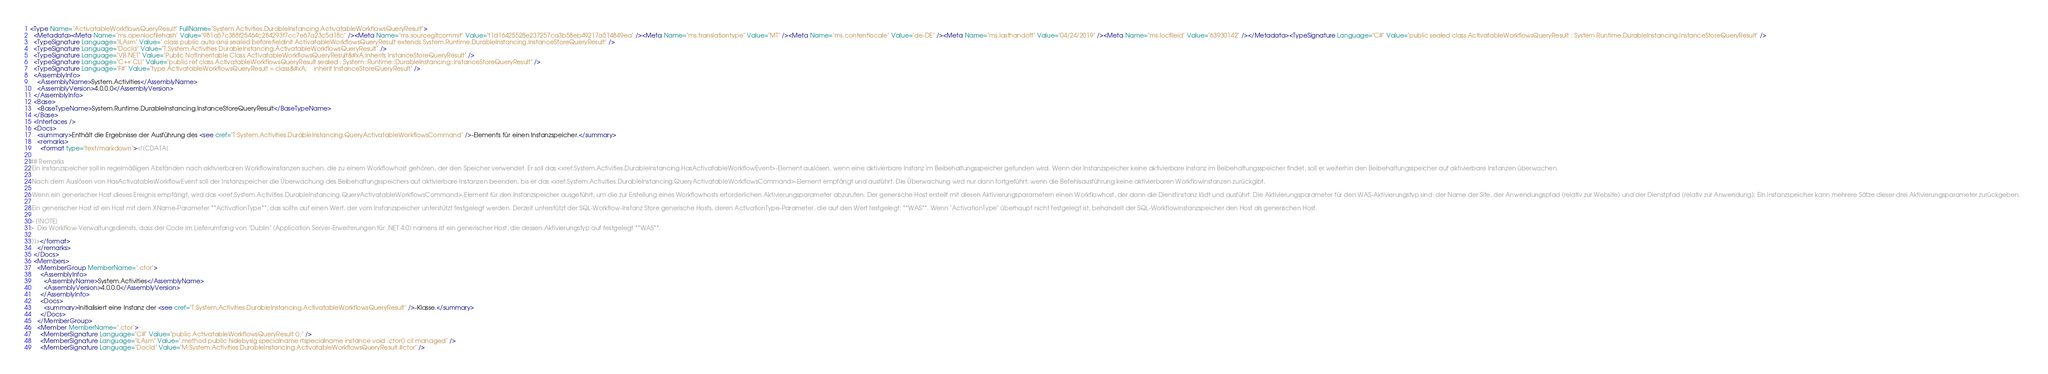Convert code to text. <code><loc_0><loc_0><loc_500><loc_500><_XML_><Type Name="ActivatableWorkflowsQueryResult" FullName="System.Activities.DurableInstancing.ActivatableWorkflowsQueryResult">
  <Metadata><Meta Name="ms.openlocfilehash" Value="981a57c388f25464c284293f7cc7e67a23c5d18c" /><Meta Name="ms.sourcegitcommit" Value="f1d16425528e237257ca3b58eb49217a514849ea" /><Meta Name="ms.translationtype" Value="MT" /><Meta Name="ms.contentlocale" Value="de-DE" /><Meta Name="ms.lasthandoff" Value="04/24/2019" /><Meta Name="ms.locfileid" Value="63930142" /></Metadata><TypeSignature Language="C#" Value="public sealed class ActivatableWorkflowsQueryResult : System.Runtime.DurableInstancing.InstanceStoreQueryResult" />
  <TypeSignature Language="ILAsm" Value=".class public auto ansi sealed beforefieldinit ActivatableWorkflowsQueryResult extends System.Runtime.DurableInstancing.InstanceStoreQueryResult" />
  <TypeSignature Language="DocId" Value="T:System.Activities.DurableInstancing.ActivatableWorkflowsQueryResult" />
  <TypeSignature Language="VB.NET" Value="Public NotInheritable Class ActivatableWorkflowsQueryResult&#xA;Inherits InstanceStoreQueryResult" />
  <TypeSignature Language="C++ CLI" Value="public ref class ActivatableWorkflowsQueryResult sealed : System::Runtime::DurableInstancing::InstanceStoreQueryResult" />
  <TypeSignature Language="F#" Value="type ActivatableWorkflowsQueryResult = class&#xA;    inherit InstanceStoreQueryResult" />
  <AssemblyInfo>
    <AssemblyName>System.Activities</AssemblyName>
    <AssemblyVersion>4.0.0.0</AssemblyVersion>
  </AssemblyInfo>
  <Base>
    <BaseTypeName>System.Runtime.DurableInstancing.InstanceStoreQueryResult</BaseTypeName>
  </Base>
  <Interfaces />
  <Docs>
    <summary>Enthält die Ergebnisse der Ausführung des <see cref="T:System.Activities.DurableInstancing.QueryActivatableWorkflowsCommand" />-Elements für einen Instanzspeicher.</summary>
    <remarks>
      <format type="text/markdown"><![CDATA[  
  
## Remarks  
 Ein Instanzspeicher soll in regelmäßigen Abständen nach aktivierbaren Workflowinstanzen suchen, die zu einem Workflowhost gehören, der den Speicher verwendet. Er soll das <xref:System.Activities.DurableInstancing.HasActivatableWorkflowEvent>-Element auslösen, wenn eine aktivierbare Instanz im Beibehaltungsspeicher gefunden wird. Wenn der Instanzspeicher keine aktivierbare Instanz im Beibehaltungsspeicher findet, soll er weiterhin den Beibehaltungsspeicher auf aktivierbare Instanzen überwachen.  
  
 Nach dem Auslösen von HasActivatableWorkflowEvent soll der Instanzspeicher die Überwachung des Beibehaltungsspeichers auf aktivierbare Instanzen beenden, bis er das <xref:System.Activities.DurableInstancing.QueryActivatableWorkflowsCommand>-Element empfängt und ausführt. Die Überwachung wird nur dann fortgeführt, wenn die Befehlsausführung keine aktivierbaren Workflowinstanzen zurückgibt.  
  
 Wenn ein generischer Host dieses Ereignis empfängt, wird das <xref:System.Activities.DurableInstancing.QueryActivatableWorkflowsCommand>-Element für den Instanzspeicher ausgeführt, um die zur Erstellung eines Workflowhosts erforderlichen Aktivierungsparameter abzurufen. Der generische Host erstellt mit diesen Aktivierungsparametern einen Workflowhost, der dann die Dienstinstanz lädt und ausführt. Die Aktivierungsparameter für den WAS-Aktivierungstyp sind: der Name der Site, der Anwendungspfad (relativ zur Website) und der Dienstpfad (relativ zur Anwendung). Ein Instanzspeicher kann mehrere Sätze dieser drei Aktivierungsparameter zurückgeben.  
  
 Ein generischer Host ist ein Host mit dem XName-Parameter **ActivationType**, das sollte auf einen Wert, der vom Instanzspeicher unterstützt festgelegt werden. Derzeit unterstützt der SQL-Workflow-Instanz Store generische Hosts, deren ActivationType-Parameter, die auf den Wert festgelegt: **WAS**. Wenn "ActivationType" überhaupt nicht festgelegt ist, behandelt der SQL-Workflowinstanzspeicher den Host als generischen Host.  
  
> [!NOTE]
>  Die Workflow-Verwaltungsdiensts, dass der Code im Lieferumfang von "Dublin" (Application Server-Erweiterungen für .NET 4.0) namens ist ein generischer Host, die dessen Aktivierungstyp auf festgelegt **WAS**.  
  
 ]]></format>
    </remarks>
  </Docs>
  <Members>
    <MemberGroup MemberName=".ctor">
      <AssemblyInfo>
        <AssemblyName>System.Activities</AssemblyName>
        <AssemblyVersion>4.0.0.0</AssemblyVersion>
      </AssemblyInfo>
      <Docs>
        <summary>Initialisiert eine Instanz der <see cref="T:System.Activities.DurableInstancing.ActivatableWorkflowsQueryResult" />-Klasse.</summary>
      </Docs>
    </MemberGroup>
    <Member MemberName=".ctor">
      <MemberSignature Language="C#" Value="public ActivatableWorkflowsQueryResult ();" />
      <MemberSignature Language="ILAsm" Value=".method public hidebysig specialname rtspecialname instance void .ctor() cil managed" />
      <MemberSignature Language="DocId" Value="M:System.Activities.DurableInstancing.ActivatableWorkflowsQueryResult.#ctor" /></code> 